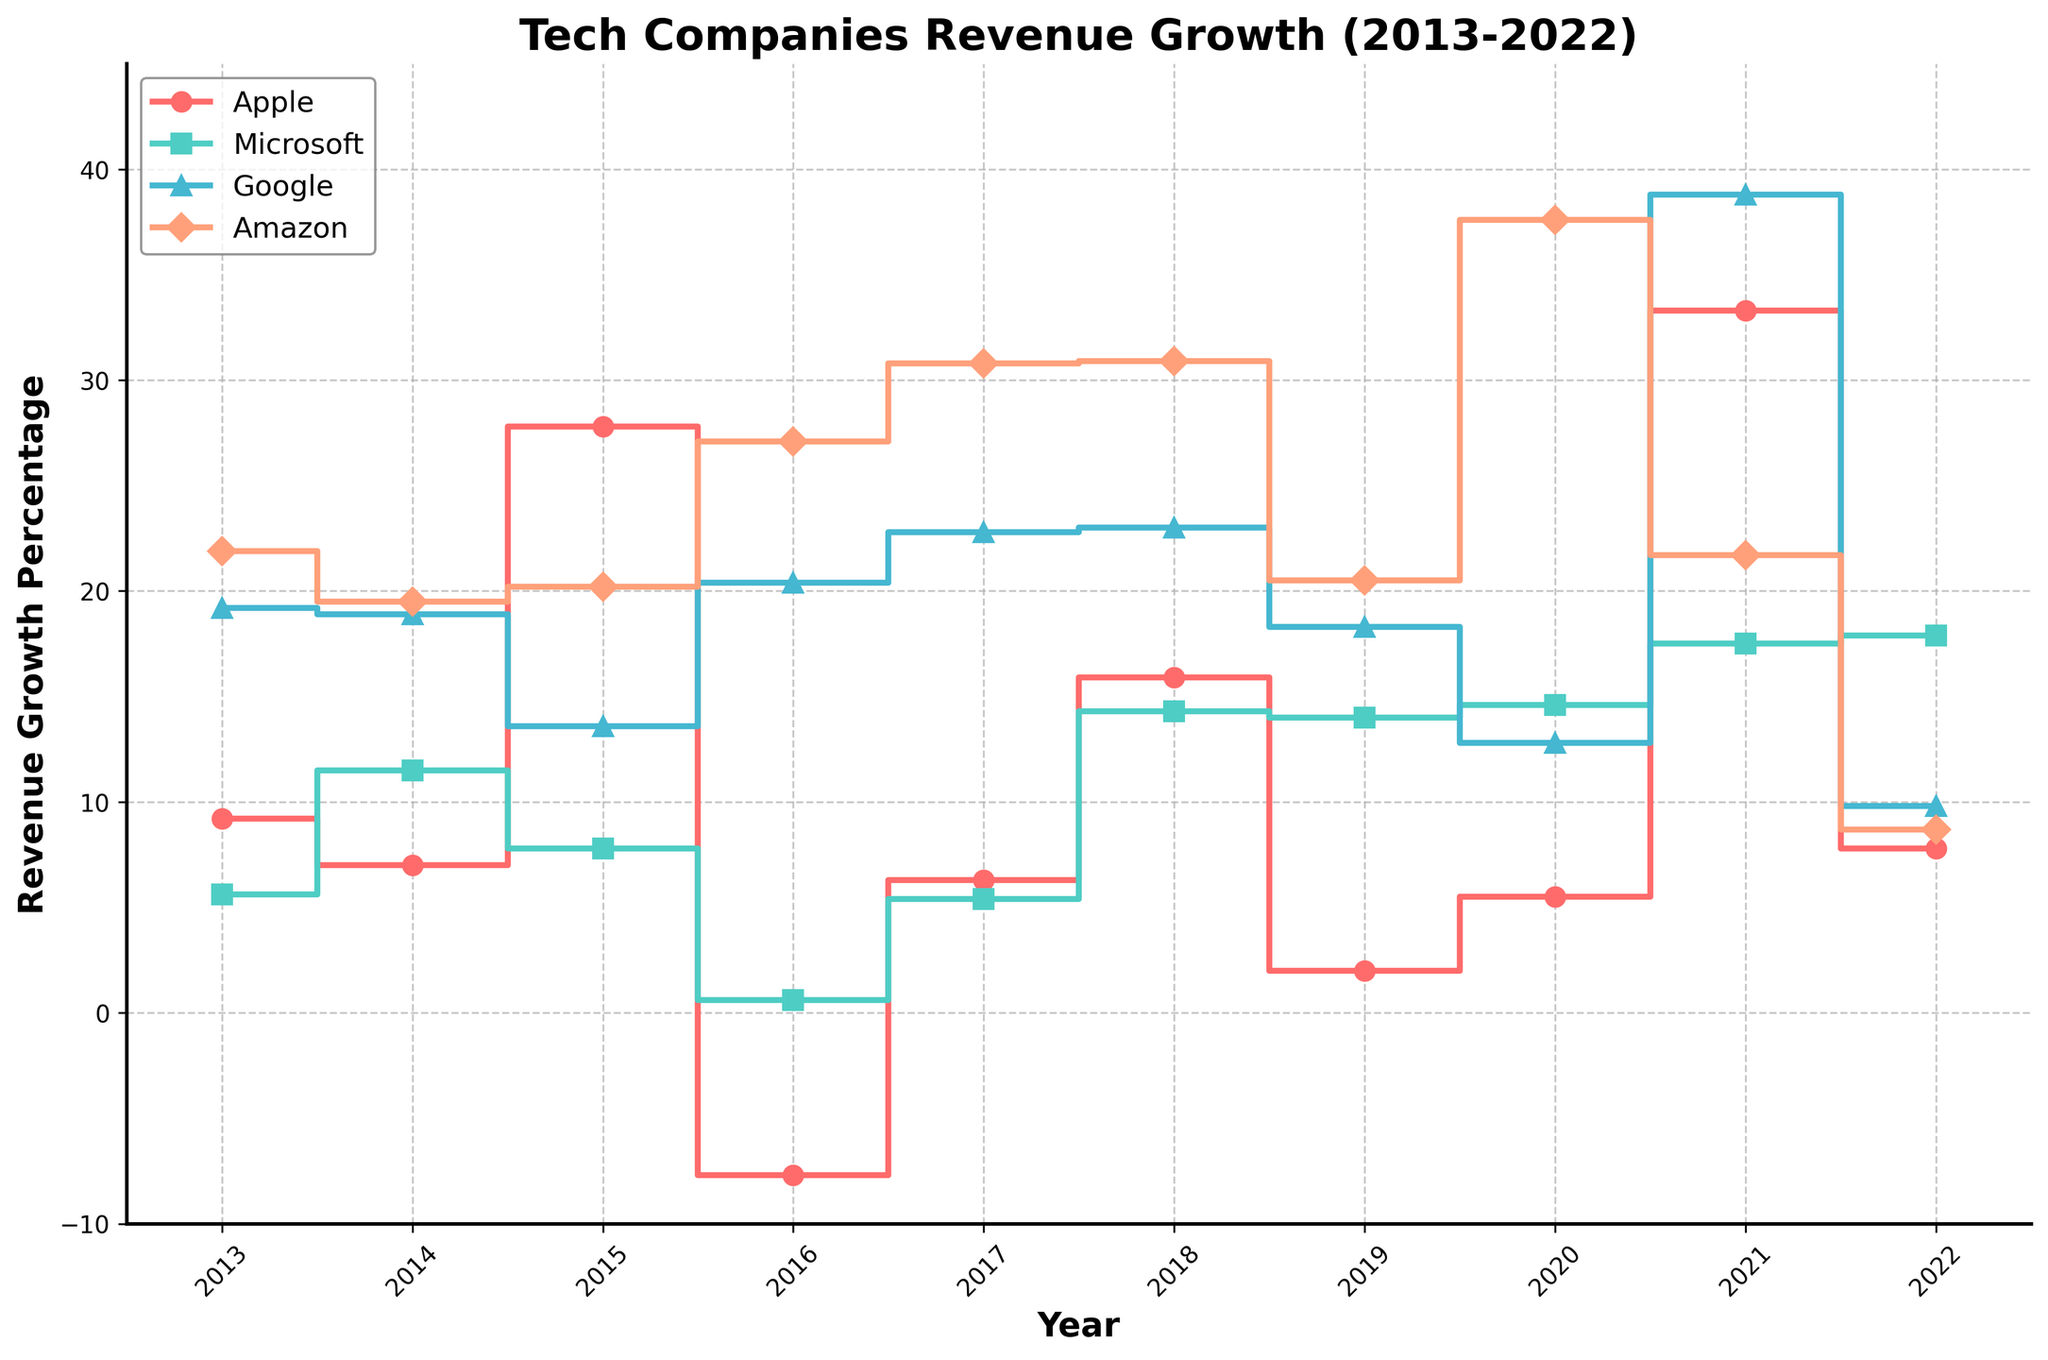What is the title of the plot? The title of the plot is typically located at the top of the figure. It provides a general description of what the plot is about.
Answer: Tech Companies Revenue Growth (2013-2022) What is the highest revenue growth percentage for Apple in the given time span? By observing the plot, we can locate the point where Apple's revenue growth percentage reaches its peak value.
Answer: 33.3 Which company showed the most consistent growth over the years? By comparing the plots for each company, we look for the one with the least variability in its stair steps. Microsoft shows consistently moderate growth with less fluctuation compared to others.
Answer: Microsoft In which year did Google experience its highest revenue growth percentage? By tracing Google's line on the plot, we identify the year corresponding to the highest point.
Answer: 2021 How does Amazon's revenue growth in 2020 compare to that in 2013? Locate the respective steps for Amazon in 2013 and 2020 and compare their heights on the vertical axis.
Answer: 2020 had higher growth (37.6%) compared to 2013 (21.9%) During which year did Apple experience a negative revenue growth, and what was the percentage? Find the step where Apple's line dips below the zero mark and read off the value.
Answer: 2016, -7.7% Which company had the highest revenue growth in 2021? By checking the points for all companies in the year 2021, identify the one with the highest position on the vertical axis.
Answer: Google How many times did Microsoft’s revenue growth percentage exceed 15%? Count the number of stair steps for Microsoft that lie above the 15% mark on the vertical axis.
Answer: 3 times Compare the average revenue growth for Google and Amazon between 2019 and 2021. Calculate the average growth for both companies over these years and compare the two averages: 
(For Google: (18.3 + 12.8 + 38.8)/3 = 23.3% 
For Amazon: (20.5 + 37.6 + 21.7)/3 = 26.6%)
Answer: Amazon (26.6%) had a higher average than Google (23.3%) Which company had the most significant drop in revenue growth percentage and in which year? Look for the steepest downward step on the plot. Apple's drop in 2016 is notable.
Answer: Apple, 2016 